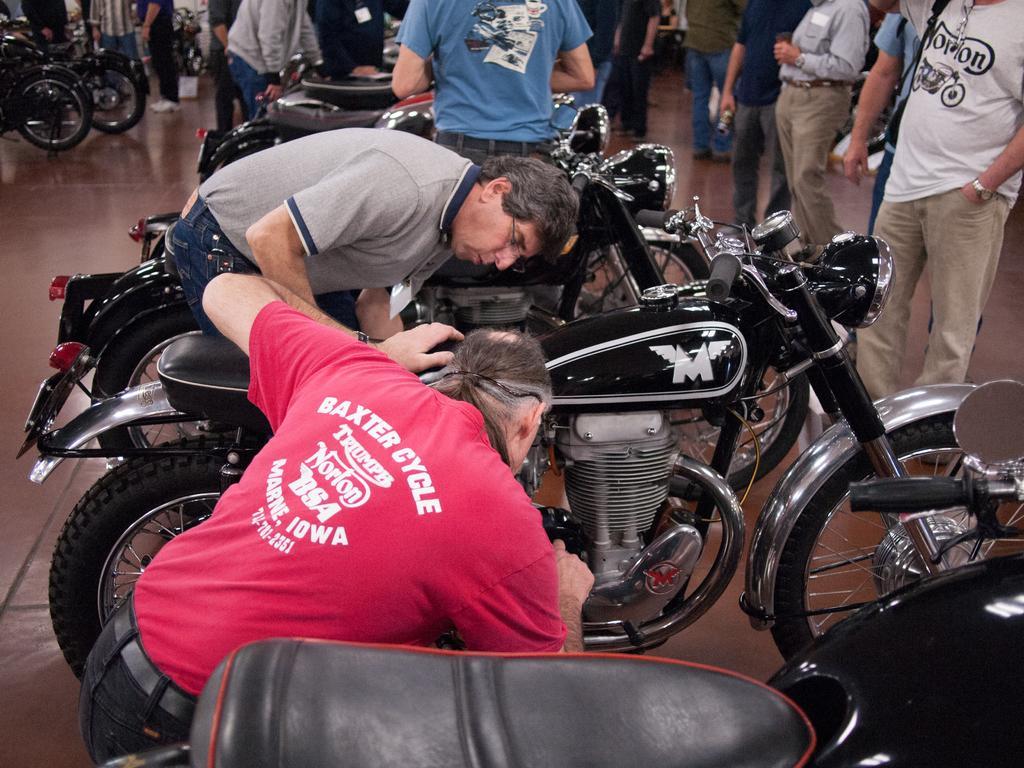Can you describe this image briefly? In this picture there is a person sitting looking at the motor cycle and there are a group of people standing over here. 